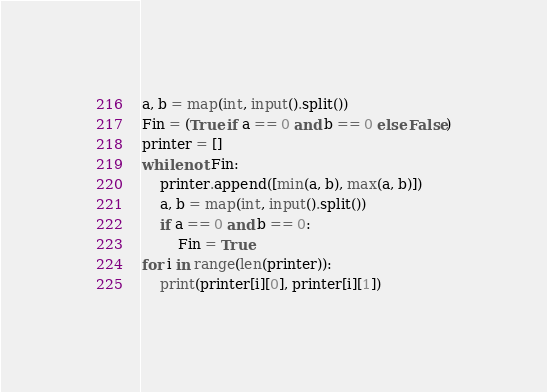Convert code to text. <code><loc_0><loc_0><loc_500><loc_500><_Python_>a, b = map(int, input().split())
Fin = (True if a == 0 and b == 0 else False)
printer = []
while not Fin:
    printer.append([min(a, b), max(a, b)])
    a, b = map(int, input().split())
    if a == 0 and b == 0:
        Fin = True
for i in range(len(printer)):
    print(printer[i][0], printer[i][1])
</code> 